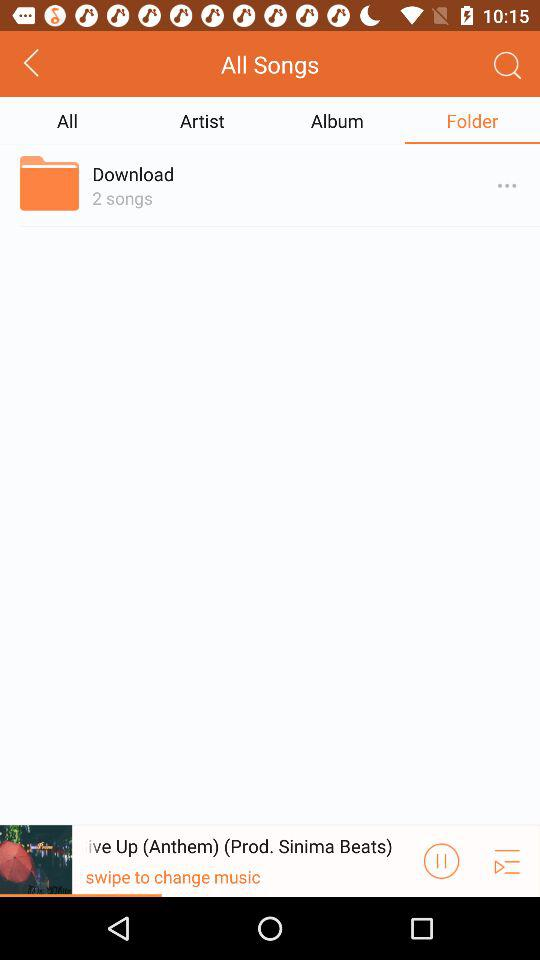How many songs are there in this folder?
Answer the question using a single word or phrase. 2 